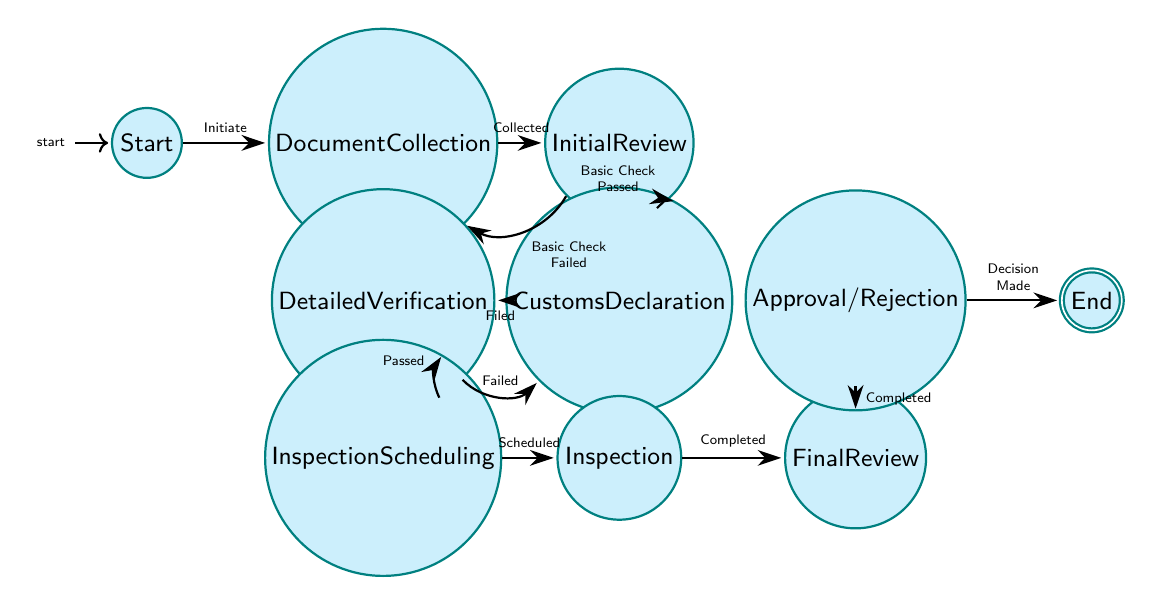What is the initial state of the import compliance procedure? The diagram starts at the state labeled "Start," which indicates the beginning of the import compliance procedure for jute products.
Answer: Start How many total states are present in the diagram? By counting the nodes, there are 10 states: Start, Document Collection, Initial Review, Customs Declaration, Detailed Verification, Inspection Scheduling, Inspection, Final Review, Approval/Rejection, and End.
Answer: 10 What action leads from "Initial Review" to "Customs Declaration"? The transition arrow from "Initial Review" to "Customs Declaration" is labeled "Basic Check Passed," indicating the action that allows movement to this state.
Answer: Basic Check Passed What happens if the "Basic Check" fails during the "Initial Review"? If the "Basic Check" fails, the transition leads back to "Document Collection," indicating that more documents need to be collected before proceeding.
Answer: Document Collection What is the final state of the import compliance procedure? The diagram ends at the state labeled "End," indicating it marks the conclusion of the import compliance procedure.
Answer: End Which state follows "Inspection"? After the "Inspection" state, the flow moves to the "Final Review," indicating that it is the next step in the process.
Answer: Final Review What is required before moving to "Inspection Scheduling"? Before moving to "Inspection Scheduling," the "Detailed Verification" process must pass successfully, as indicated by the transition labeled "Verification Passed."
Answer: Verification Passed How many edges are connected to the "Final Review" state? "Final Review" has one outgoing edge leading to "Approval/Rejection," indicating a single transition from this state.
Answer: 1 What does the transition labeled "Decision Made" signify? The transition labeled "Decision Made" signifies the final outcome of the trade compliance process, determining whether the import is approved or rejected, as it leads to the "End" state.
Answer: End 